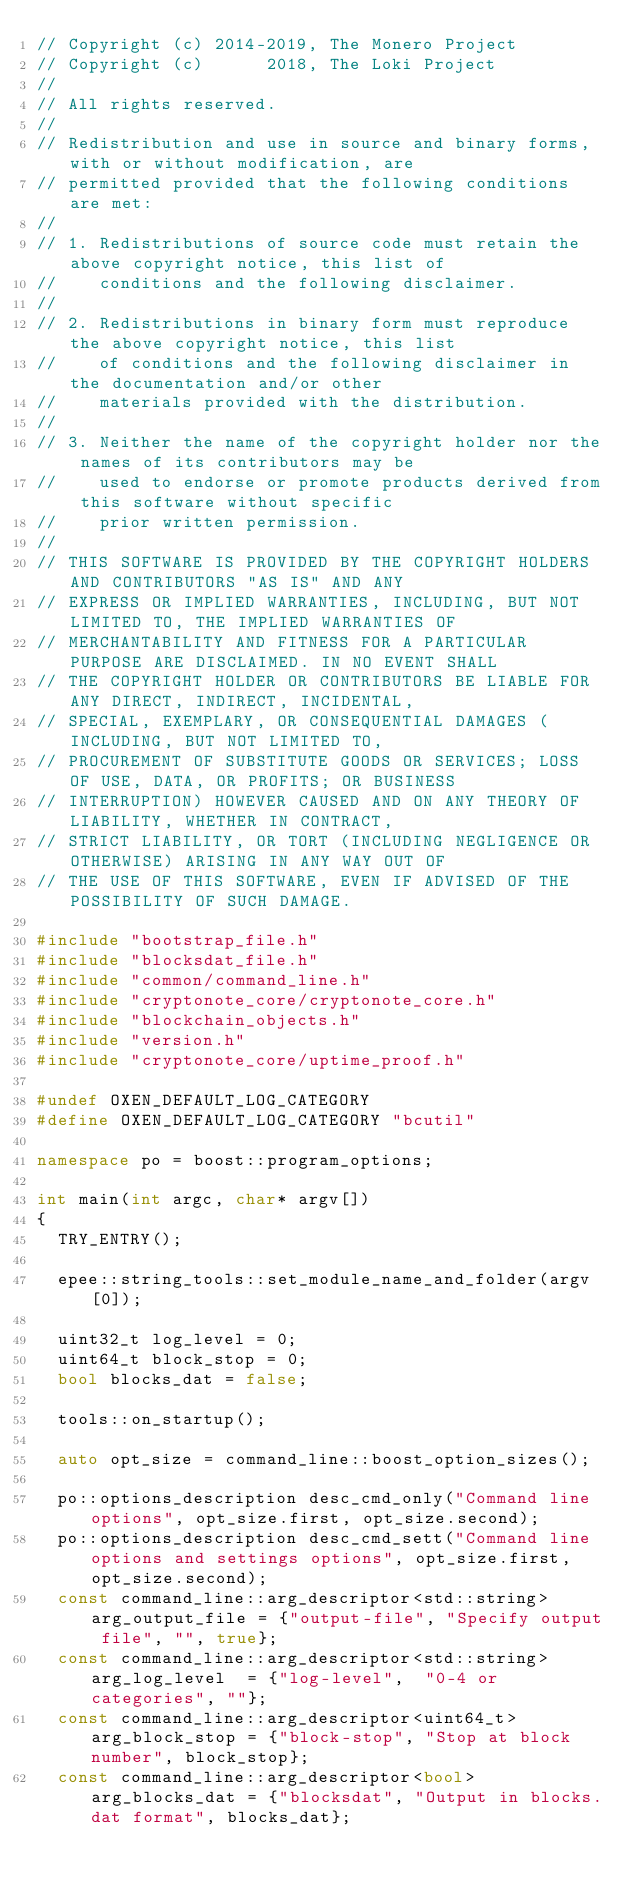Convert code to text. <code><loc_0><loc_0><loc_500><loc_500><_C++_>// Copyright (c) 2014-2019, The Monero Project
// Copyright (c)      2018, The Loki Project
//
// All rights reserved.
//
// Redistribution and use in source and binary forms, with or without modification, are
// permitted provided that the following conditions are met:
//
// 1. Redistributions of source code must retain the above copyright notice, this list of
//    conditions and the following disclaimer.
//
// 2. Redistributions in binary form must reproduce the above copyright notice, this list
//    of conditions and the following disclaimer in the documentation and/or other
//    materials provided with the distribution.
//
// 3. Neither the name of the copyright holder nor the names of its contributors may be
//    used to endorse or promote products derived from this software without specific
//    prior written permission.
//
// THIS SOFTWARE IS PROVIDED BY THE COPYRIGHT HOLDERS AND CONTRIBUTORS "AS IS" AND ANY
// EXPRESS OR IMPLIED WARRANTIES, INCLUDING, BUT NOT LIMITED TO, THE IMPLIED WARRANTIES OF
// MERCHANTABILITY AND FITNESS FOR A PARTICULAR PURPOSE ARE DISCLAIMED. IN NO EVENT SHALL
// THE COPYRIGHT HOLDER OR CONTRIBUTORS BE LIABLE FOR ANY DIRECT, INDIRECT, INCIDENTAL,
// SPECIAL, EXEMPLARY, OR CONSEQUENTIAL DAMAGES (INCLUDING, BUT NOT LIMITED TO,
// PROCUREMENT OF SUBSTITUTE GOODS OR SERVICES; LOSS OF USE, DATA, OR PROFITS; OR BUSINESS
// INTERRUPTION) HOWEVER CAUSED AND ON ANY THEORY OF LIABILITY, WHETHER IN CONTRACT,
// STRICT LIABILITY, OR TORT (INCLUDING NEGLIGENCE OR OTHERWISE) ARISING IN ANY WAY OUT OF
// THE USE OF THIS SOFTWARE, EVEN IF ADVISED OF THE POSSIBILITY OF SUCH DAMAGE.

#include "bootstrap_file.h"
#include "blocksdat_file.h"
#include "common/command_line.h"
#include "cryptonote_core/cryptonote_core.h"
#include "blockchain_objects.h"
#include "version.h"
#include "cryptonote_core/uptime_proof.h"

#undef OXEN_DEFAULT_LOG_CATEGORY
#define OXEN_DEFAULT_LOG_CATEGORY "bcutil"

namespace po = boost::program_options;

int main(int argc, char* argv[])
{
  TRY_ENTRY();

  epee::string_tools::set_module_name_and_folder(argv[0]);

  uint32_t log_level = 0;
  uint64_t block_stop = 0;
  bool blocks_dat = false;

  tools::on_startup();

  auto opt_size = command_line::boost_option_sizes();

  po::options_description desc_cmd_only("Command line options", opt_size.first, opt_size.second);
  po::options_description desc_cmd_sett("Command line options and settings options", opt_size.first, opt_size.second);
  const command_line::arg_descriptor<std::string> arg_output_file = {"output-file", "Specify output file", "", true};
  const command_line::arg_descriptor<std::string> arg_log_level  = {"log-level",  "0-4 or categories", ""};
  const command_line::arg_descriptor<uint64_t> arg_block_stop = {"block-stop", "Stop at block number", block_stop};
  const command_line::arg_descriptor<bool> arg_blocks_dat = {"blocksdat", "Output in blocks.dat format", blocks_dat};

</code> 